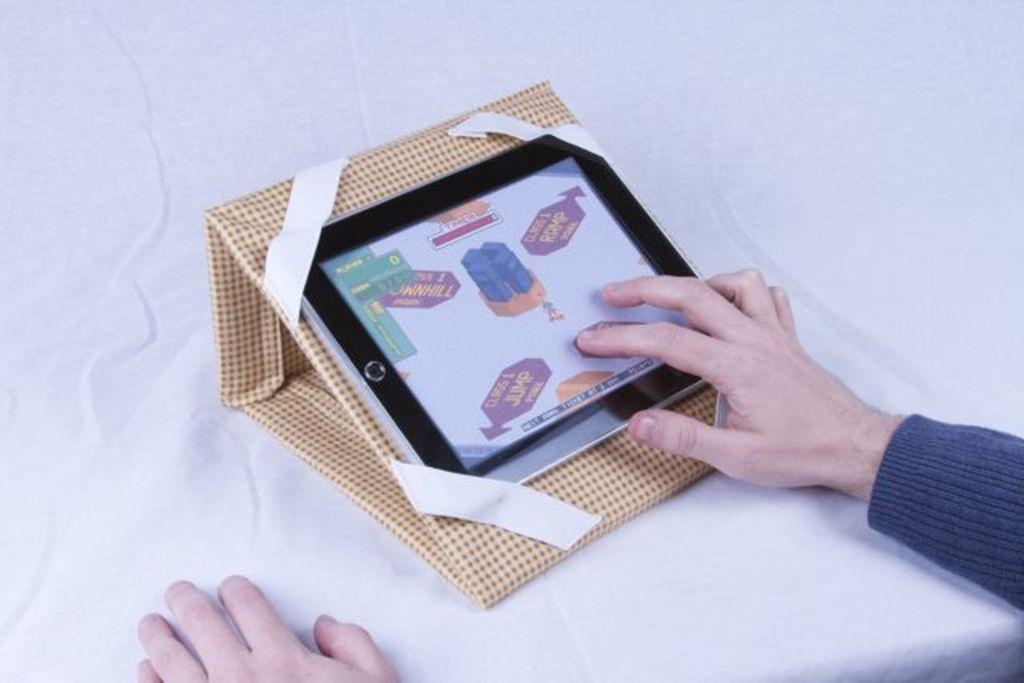What is the main object in the image? There is an object on a white surface in the image. Can you describe the person's hands in the image? Two hands of a person are visible in the image, and one of the hands is placed on the object. What type of animals can be seen in the cellar in the image? There is no cellar or animals present in the image; it features an object on a white surface and a person's hands. 